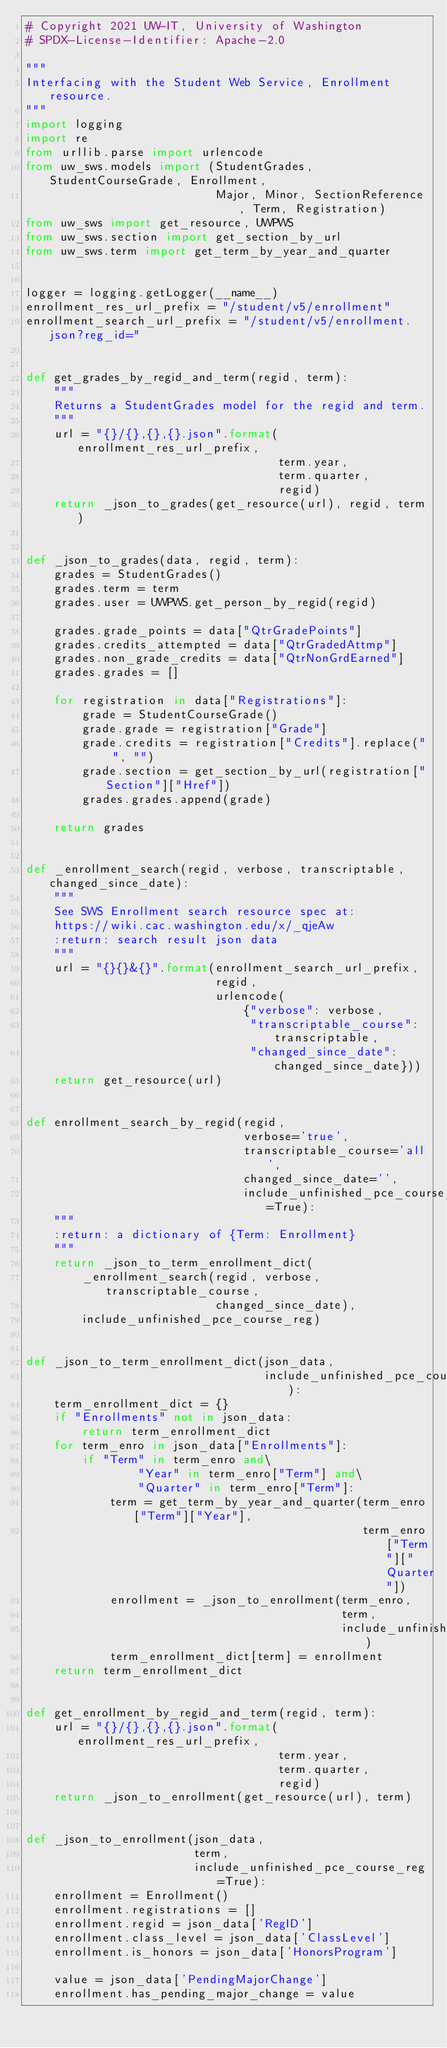<code> <loc_0><loc_0><loc_500><loc_500><_Python_># Copyright 2021 UW-IT, University of Washington
# SPDX-License-Identifier: Apache-2.0

"""
Interfacing with the Student Web Service, Enrollment resource.
"""
import logging
import re
from urllib.parse import urlencode
from uw_sws.models import (StudentGrades, StudentCourseGrade, Enrollment,
                           Major, Minor, SectionReference, Term, Registration)
from uw_sws import get_resource, UWPWS
from uw_sws.section import get_section_by_url
from uw_sws.term import get_term_by_year_and_quarter


logger = logging.getLogger(__name__)
enrollment_res_url_prefix = "/student/v5/enrollment"
enrollment_search_url_prefix = "/student/v5/enrollment.json?reg_id="


def get_grades_by_regid_and_term(regid, term):
    """
    Returns a StudentGrades model for the regid and term.
    """
    url = "{}/{},{},{}.json".format(enrollment_res_url_prefix,
                                    term.year,
                                    term.quarter,
                                    regid)
    return _json_to_grades(get_resource(url), regid, term)


def _json_to_grades(data, regid, term):
    grades = StudentGrades()
    grades.term = term
    grades.user = UWPWS.get_person_by_regid(regid)

    grades.grade_points = data["QtrGradePoints"]
    grades.credits_attempted = data["QtrGradedAttmp"]
    grades.non_grade_credits = data["QtrNonGrdEarned"]
    grades.grades = []

    for registration in data["Registrations"]:
        grade = StudentCourseGrade()
        grade.grade = registration["Grade"]
        grade.credits = registration["Credits"].replace(" ", "")
        grade.section = get_section_by_url(registration["Section"]["Href"])
        grades.grades.append(grade)

    return grades


def _enrollment_search(regid, verbose, transcriptable, changed_since_date):
    """
    See SWS Enrollment search resource spec at:
    https://wiki.cac.washington.edu/x/_qjeAw
    :return: search result json data
    """
    url = "{}{}&{}".format(enrollment_search_url_prefix,
                           regid,
                           urlencode(
                               {"verbose": verbose,
                                "transcriptable_course": transcriptable,
                                "changed_since_date": changed_since_date}))
    return get_resource(url)


def enrollment_search_by_regid(regid,
                               verbose='true',
                               transcriptable_course='all',
                               changed_since_date='',
                               include_unfinished_pce_course_reg=True):
    """
    :return: a dictionary of {Term: Enrollment}
    """
    return _json_to_term_enrollment_dict(
        _enrollment_search(regid, verbose, transcriptable_course,
                           changed_since_date),
        include_unfinished_pce_course_reg)


def _json_to_term_enrollment_dict(json_data,
                                  include_unfinished_pce_course_reg):
    term_enrollment_dict = {}
    if "Enrollments" not in json_data:
        return term_enrollment_dict
    for term_enro in json_data["Enrollments"]:
        if "Term" in term_enro and\
                "Year" in term_enro["Term"] and\
                "Quarter" in term_enro["Term"]:
            term = get_term_by_year_and_quarter(term_enro["Term"]["Year"],
                                                term_enro["Term"]["Quarter"])
            enrollment = _json_to_enrollment(term_enro,
                                             term,
                                             include_unfinished_pce_course_reg)
            term_enrollment_dict[term] = enrollment
    return term_enrollment_dict


def get_enrollment_by_regid_and_term(regid, term):
    url = "{}/{},{},{}.json".format(enrollment_res_url_prefix,
                                    term.year,
                                    term.quarter,
                                    regid)
    return _json_to_enrollment(get_resource(url), term)


def _json_to_enrollment(json_data,
                        term,
                        include_unfinished_pce_course_reg=True):
    enrollment = Enrollment()
    enrollment.registrations = []
    enrollment.regid = json_data['RegID']
    enrollment.class_level = json_data['ClassLevel']
    enrollment.is_honors = json_data['HonorsProgram']

    value = json_data['PendingMajorChange']
    enrollment.has_pending_major_change = value
</code> 